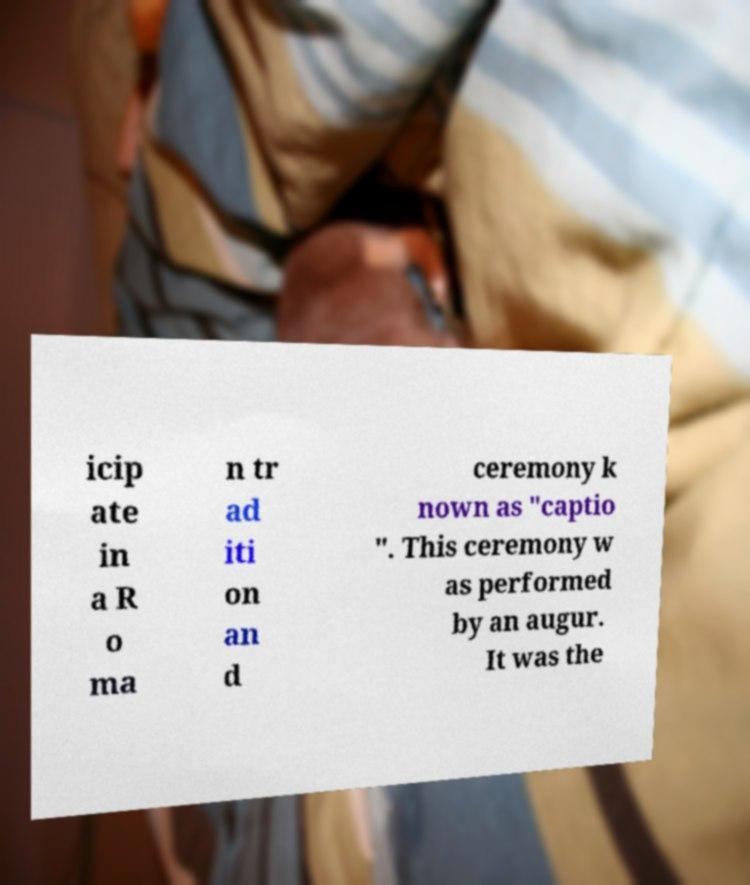I need the written content from this picture converted into text. Can you do that? icip ate in a R o ma n tr ad iti on an d ceremony k nown as "captio ". This ceremony w as performed by an augur. It was the 